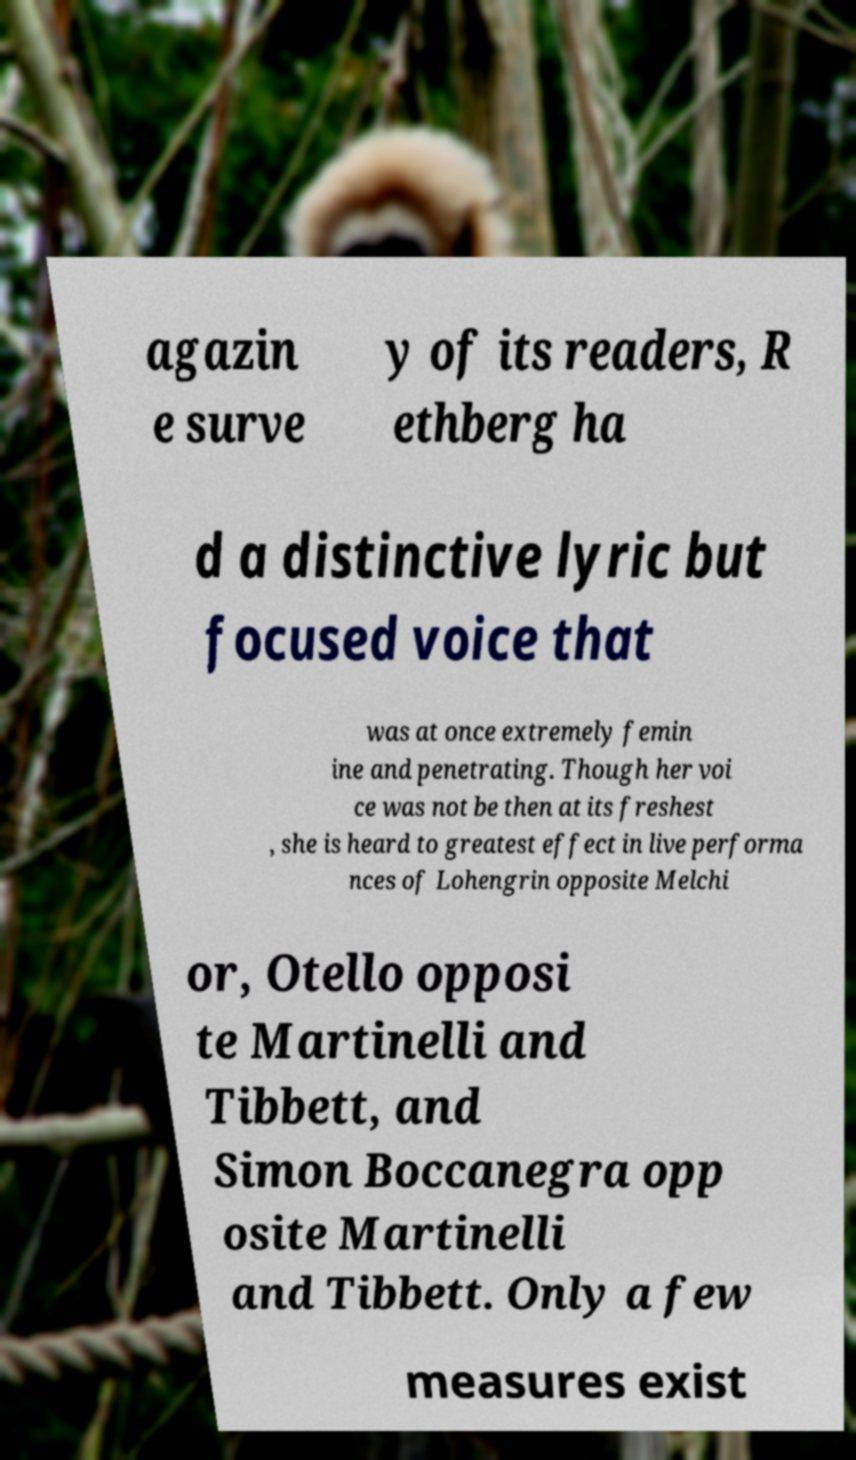There's text embedded in this image that I need extracted. Can you transcribe it verbatim? agazin e surve y of its readers, R ethberg ha d a distinctive lyric but focused voice that was at once extremely femin ine and penetrating. Though her voi ce was not be then at its freshest , she is heard to greatest effect in live performa nces of Lohengrin opposite Melchi or, Otello opposi te Martinelli and Tibbett, and Simon Boccanegra opp osite Martinelli and Tibbett. Only a few measures exist 